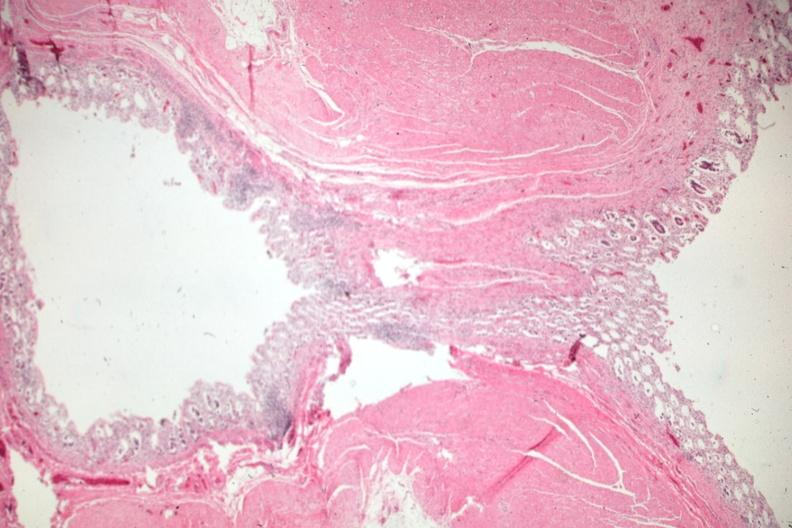s amyloidosis present?
Answer the question using a single word or phrase. No 